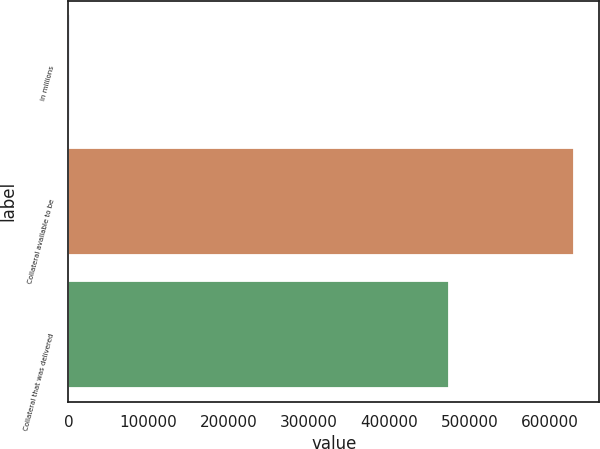Convert chart to OTSL. <chart><loc_0><loc_0><loc_500><loc_500><bar_chart><fcel>in millions<fcel>Collateral available to be<fcel>Collateral that was delivered<nl><fcel>2014<fcel>630046<fcel>474057<nl></chart> 